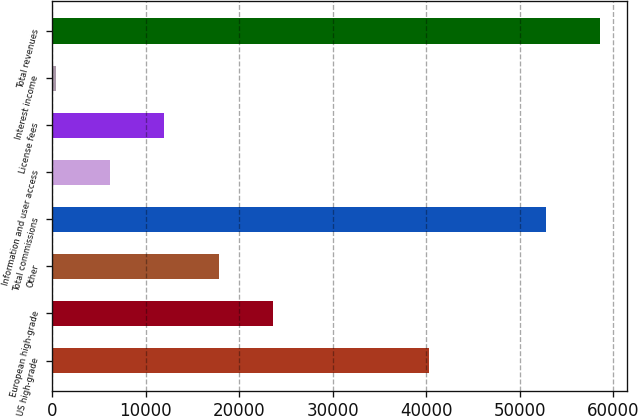Convert chart to OTSL. <chart><loc_0><loc_0><loc_500><loc_500><bar_chart><fcel>US high-grade<fcel>European high-grade<fcel>Other<fcel>Total commissions<fcel>Information and user access<fcel>License fees<fcel>Interest income<fcel>Total revenues<nl><fcel>40310<fcel>23606.6<fcel>17797.7<fcel>52800<fcel>6179.9<fcel>11988.8<fcel>371<fcel>58608.9<nl></chart> 